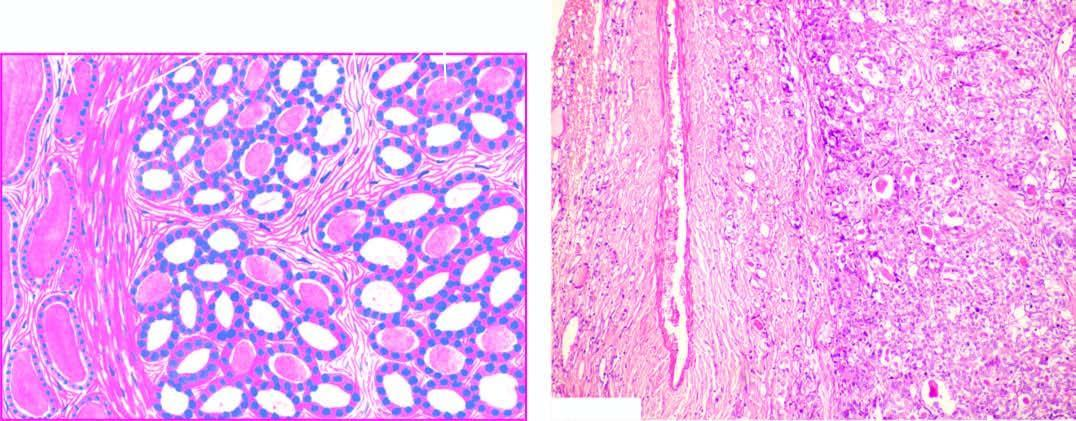what is the tumour well-encapsulated with?
Answer the question using a single word or phrase. Compression of surrounding thyroid parenchyma 